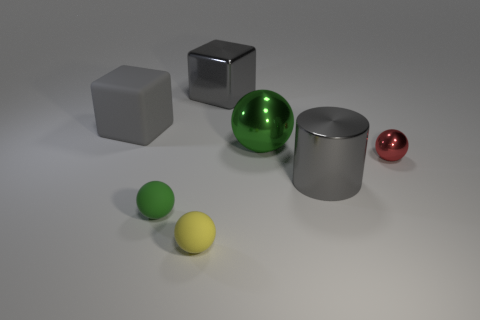Subtract all big green shiny spheres. How many spheres are left? 3 Subtract all brown cylinders. How many green balls are left? 2 Add 2 cubes. How many objects exist? 9 Subtract all red balls. How many balls are left? 3 Subtract all spheres. How many objects are left? 3 Subtract all gray balls. Subtract all gray blocks. How many balls are left? 4 Add 7 green metallic spheres. How many green metallic spheres exist? 8 Subtract 0 red cubes. How many objects are left? 7 Subtract all large shiny cylinders. Subtract all big shiny spheres. How many objects are left? 5 Add 1 small red shiny objects. How many small red shiny objects are left? 2 